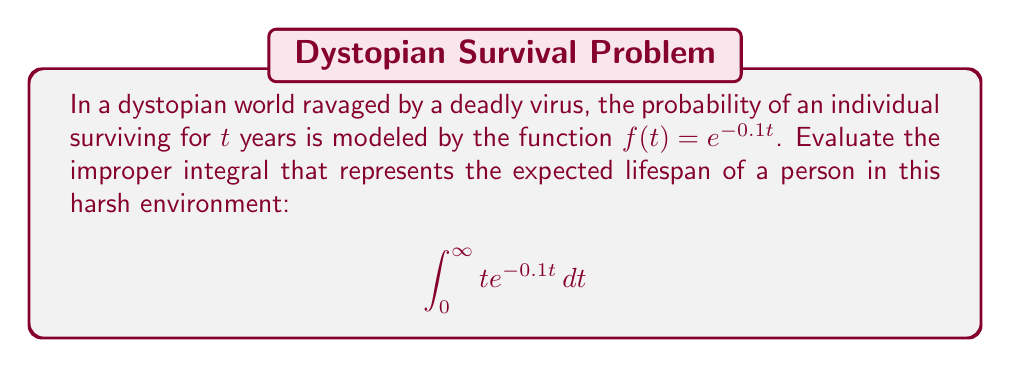Help me with this question. To evaluate this improper integral, we'll use integration by parts. Let:

$u = t$, $du = dt$
$dv = e^{-0.1t} dt$, $v = -10e^{-0.1t}$

Applying the integration by parts formula:

$$\int u dv = uv - \int v du$$

We get:

$$\int_0^\infty te^{-0.1t} dt = \left[-10te^{-0.1t}\right]_0^\infty + 10\int_0^\infty e^{-0.1t} dt$$

For the first term:
$\lim_{t \to \infty} -10te^{-0.1t} = 0$ (using L'Hôpital's rule)
At $t = 0$: $-10 \cdot 0 \cdot e^0 = 0$

So, the first term evaluates to 0.

For the second term:
$$10\int_0^\infty e^{-0.1t} dt = 10 \left[-10e^{-0.1t}\right]_0^\infty = 10(0 - (-10)) = 100$$

Therefore, the improper integral evaluates to 100.

This result means that in this dystopian environment, the expected lifespan of an individual is 100 years, despite the constant threat of the virus. This seemingly optimistic outcome in a bleak world could serve as an intriguing plot element in a dystopian novel, perhaps highlighting the resilience of humanity or the deceptive nature of statistics in a world where survival doesn't equate to a high quality of life.
Answer: 100 years 